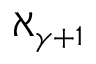Convert formula to latex. <formula><loc_0><loc_0><loc_500><loc_500>\aleph _ { \gamma + 1 }</formula> 